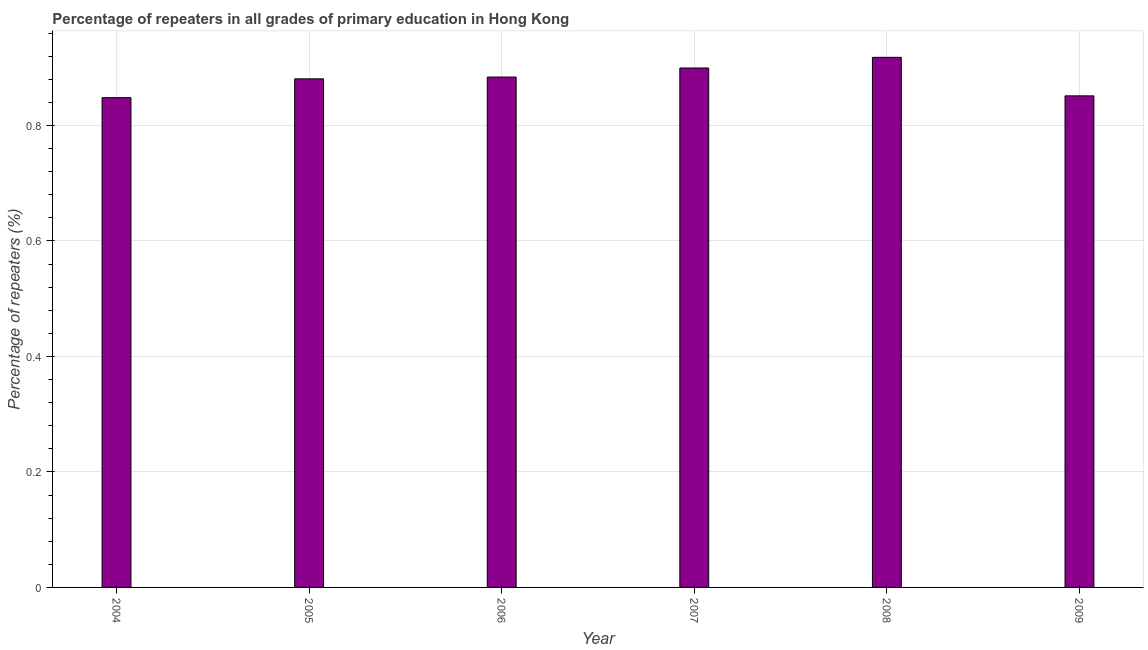Does the graph contain grids?
Provide a succinct answer. Yes. What is the title of the graph?
Your answer should be compact. Percentage of repeaters in all grades of primary education in Hong Kong. What is the label or title of the Y-axis?
Ensure brevity in your answer.  Percentage of repeaters (%). What is the percentage of repeaters in primary education in 2009?
Provide a short and direct response. 0.85. Across all years, what is the maximum percentage of repeaters in primary education?
Provide a short and direct response. 0.92. Across all years, what is the minimum percentage of repeaters in primary education?
Provide a short and direct response. 0.85. In which year was the percentage of repeaters in primary education minimum?
Give a very brief answer. 2004. What is the sum of the percentage of repeaters in primary education?
Ensure brevity in your answer.  5.28. What is the difference between the percentage of repeaters in primary education in 2006 and 2008?
Ensure brevity in your answer.  -0.03. What is the median percentage of repeaters in primary education?
Offer a terse response. 0.88. In how many years, is the percentage of repeaters in primary education greater than 0.32 %?
Make the answer very short. 6. Is the percentage of repeaters in primary education in 2005 less than that in 2007?
Your answer should be compact. Yes. Is the difference between the percentage of repeaters in primary education in 2005 and 2007 greater than the difference between any two years?
Offer a terse response. No. What is the difference between the highest and the second highest percentage of repeaters in primary education?
Your answer should be compact. 0.02. Is the sum of the percentage of repeaters in primary education in 2005 and 2007 greater than the maximum percentage of repeaters in primary education across all years?
Give a very brief answer. Yes. What is the difference between the highest and the lowest percentage of repeaters in primary education?
Provide a succinct answer. 0.07. In how many years, is the percentage of repeaters in primary education greater than the average percentage of repeaters in primary education taken over all years?
Make the answer very short. 4. How many bars are there?
Offer a terse response. 6. Are all the bars in the graph horizontal?
Keep it short and to the point. No. Are the values on the major ticks of Y-axis written in scientific E-notation?
Give a very brief answer. No. What is the Percentage of repeaters (%) of 2004?
Offer a terse response. 0.85. What is the Percentage of repeaters (%) in 2005?
Give a very brief answer. 0.88. What is the Percentage of repeaters (%) of 2006?
Provide a succinct answer. 0.88. What is the Percentage of repeaters (%) in 2007?
Keep it short and to the point. 0.9. What is the Percentage of repeaters (%) in 2008?
Your answer should be compact. 0.92. What is the Percentage of repeaters (%) in 2009?
Provide a short and direct response. 0.85. What is the difference between the Percentage of repeaters (%) in 2004 and 2005?
Ensure brevity in your answer.  -0.03. What is the difference between the Percentage of repeaters (%) in 2004 and 2006?
Ensure brevity in your answer.  -0.04. What is the difference between the Percentage of repeaters (%) in 2004 and 2007?
Your answer should be compact. -0.05. What is the difference between the Percentage of repeaters (%) in 2004 and 2008?
Provide a succinct answer. -0.07. What is the difference between the Percentage of repeaters (%) in 2004 and 2009?
Your answer should be very brief. -0. What is the difference between the Percentage of repeaters (%) in 2005 and 2006?
Make the answer very short. -0. What is the difference between the Percentage of repeaters (%) in 2005 and 2007?
Make the answer very short. -0.02. What is the difference between the Percentage of repeaters (%) in 2005 and 2008?
Your answer should be very brief. -0.04. What is the difference between the Percentage of repeaters (%) in 2005 and 2009?
Ensure brevity in your answer.  0.03. What is the difference between the Percentage of repeaters (%) in 2006 and 2007?
Offer a very short reply. -0.02. What is the difference between the Percentage of repeaters (%) in 2006 and 2008?
Your answer should be very brief. -0.03. What is the difference between the Percentage of repeaters (%) in 2006 and 2009?
Your answer should be compact. 0.03. What is the difference between the Percentage of repeaters (%) in 2007 and 2008?
Give a very brief answer. -0.02. What is the difference between the Percentage of repeaters (%) in 2007 and 2009?
Give a very brief answer. 0.05. What is the difference between the Percentage of repeaters (%) in 2008 and 2009?
Your response must be concise. 0.07. What is the ratio of the Percentage of repeaters (%) in 2004 to that in 2006?
Offer a terse response. 0.96. What is the ratio of the Percentage of repeaters (%) in 2004 to that in 2007?
Provide a succinct answer. 0.94. What is the ratio of the Percentage of repeaters (%) in 2004 to that in 2008?
Your answer should be very brief. 0.92. What is the ratio of the Percentage of repeaters (%) in 2005 to that in 2007?
Make the answer very short. 0.98. What is the ratio of the Percentage of repeaters (%) in 2005 to that in 2008?
Keep it short and to the point. 0.96. What is the ratio of the Percentage of repeaters (%) in 2005 to that in 2009?
Keep it short and to the point. 1.03. What is the ratio of the Percentage of repeaters (%) in 2006 to that in 2007?
Give a very brief answer. 0.98. What is the ratio of the Percentage of repeaters (%) in 2006 to that in 2008?
Your response must be concise. 0.96. What is the ratio of the Percentage of repeaters (%) in 2006 to that in 2009?
Provide a succinct answer. 1.04. What is the ratio of the Percentage of repeaters (%) in 2007 to that in 2009?
Your answer should be compact. 1.06. What is the ratio of the Percentage of repeaters (%) in 2008 to that in 2009?
Offer a terse response. 1.08. 